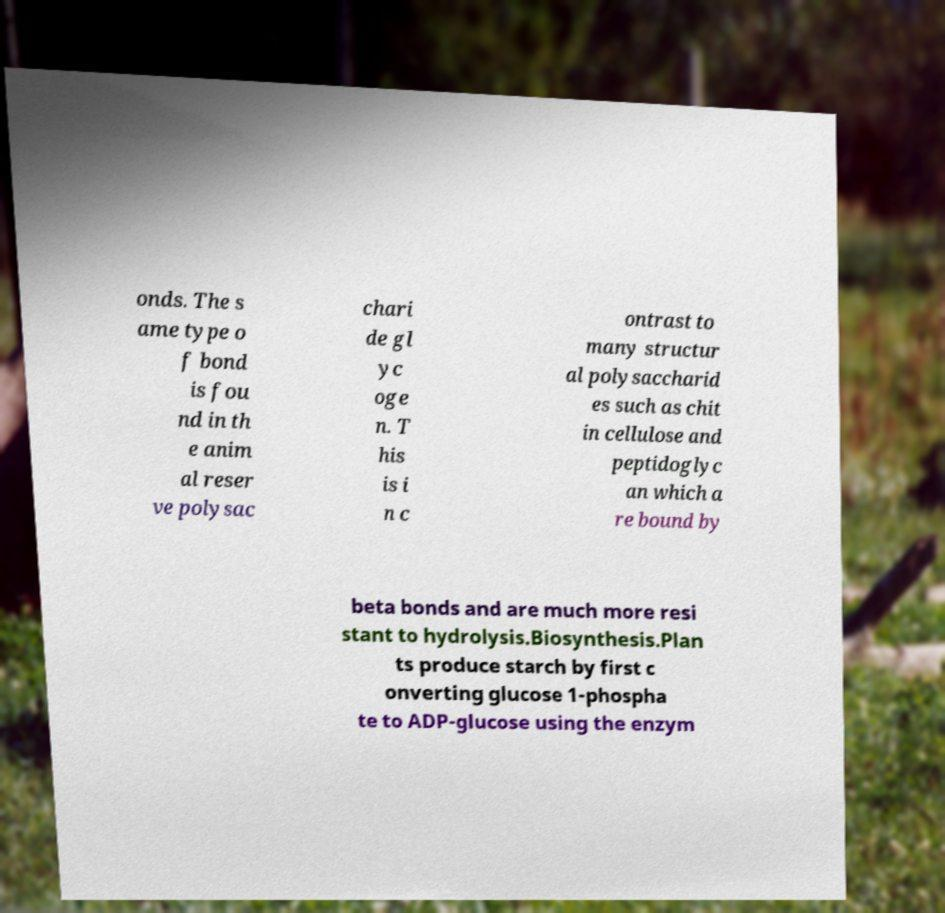What messages or text are displayed in this image? I need them in a readable, typed format. onds. The s ame type o f bond is fou nd in th e anim al reser ve polysac chari de gl yc oge n. T his is i n c ontrast to many structur al polysaccharid es such as chit in cellulose and peptidoglyc an which a re bound by beta bonds and are much more resi stant to hydrolysis.Biosynthesis.Plan ts produce starch by first c onverting glucose 1-phospha te to ADP-glucose using the enzym 